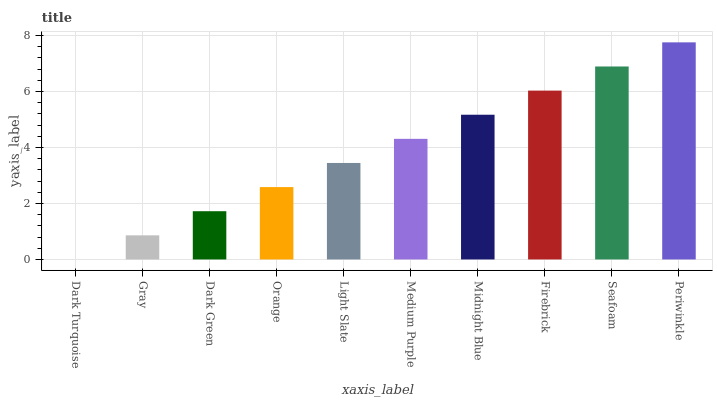Is Dark Turquoise the minimum?
Answer yes or no. Yes. Is Periwinkle the maximum?
Answer yes or no. Yes. Is Gray the minimum?
Answer yes or no. No. Is Gray the maximum?
Answer yes or no. No. Is Gray greater than Dark Turquoise?
Answer yes or no. Yes. Is Dark Turquoise less than Gray?
Answer yes or no. Yes. Is Dark Turquoise greater than Gray?
Answer yes or no. No. Is Gray less than Dark Turquoise?
Answer yes or no. No. Is Medium Purple the high median?
Answer yes or no. Yes. Is Light Slate the low median?
Answer yes or no. Yes. Is Firebrick the high median?
Answer yes or no. No. Is Dark Green the low median?
Answer yes or no. No. 